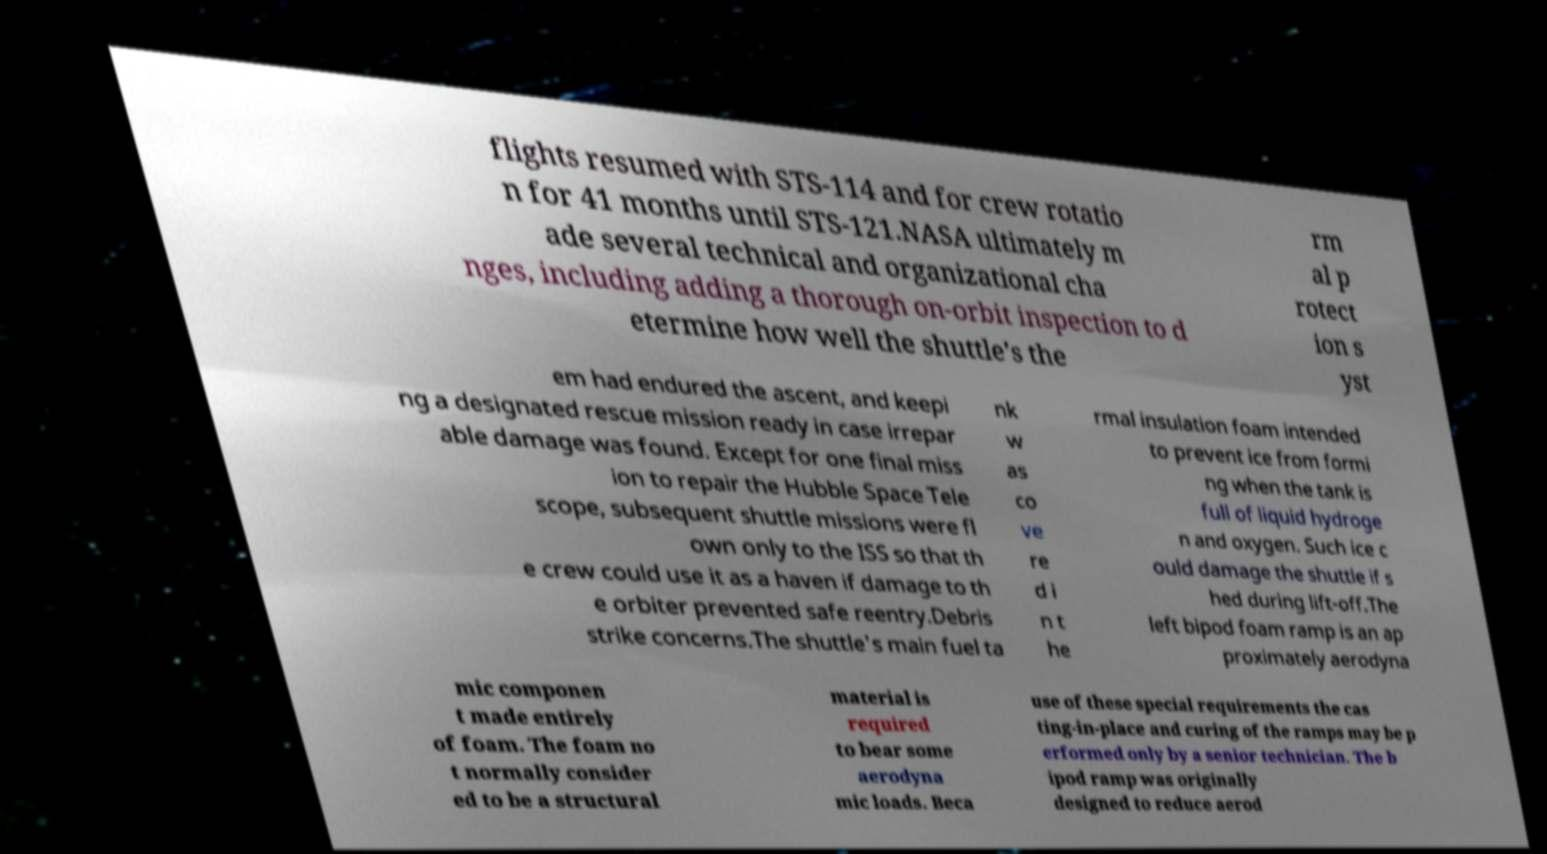Could you extract and type out the text from this image? flights resumed with STS-114 and for crew rotatio n for 41 months until STS-121.NASA ultimately m ade several technical and organizational cha nges, including adding a thorough on-orbit inspection to d etermine how well the shuttle's the rm al p rotect ion s yst em had endured the ascent, and keepi ng a designated rescue mission ready in case irrepar able damage was found. Except for one final miss ion to repair the Hubble Space Tele scope, subsequent shuttle missions were fl own only to the ISS so that th e crew could use it as a haven if damage to th e orbiter prevented safe reentry.Debris strike concerns.The shuttle's main fuel ta nk w as co ve re d i n t he rmal insulation foam intended to prevent ice from formi ng when the tank is full of liquid hydroge n and oxygen. Such ice c ould damage the shuttle if s hed during lift-off.The left bipod foam ramp is an ap proximately aerodyna mic componen t made entirely of foam. The foam no t normally consider ed to be a structural material is required to bear some aerodyna mic loads. Beca use of these special requirements the cas ting-in-place and curing of the ramps may be p erformed only by a senior technician. The b ipod ramp was originally designed to reduce aerod 